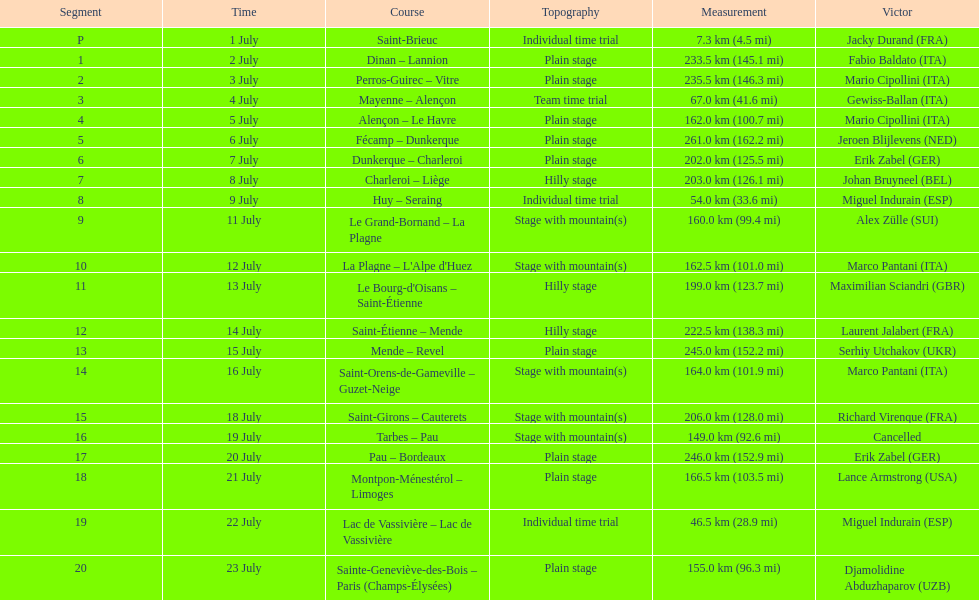Which routes were at least 100 km? Dinan - Lannion, Perros-Guirec - Vitre, Alençon - Le Havre, Fécamp - Dunkerque, Dunkerque - Charleroi, Charleroi - Liège, Le Grand-Bornand - La Plagne, La Plagne - L'Alpe d'Huez, Le Bourg-d'Oisans - Saint-Étienne, Saint-Étienne - Mende, Mende - Revel, Saint-Orens-de-Gameville - Guzet-Neige, Saint-Girons - Cauterets, Tarbes - Pau, Pau - Bordeaux, Montpon-Ménestérol - Limoges, Sainte-Geneviève-des-Bois - Paris (Champs-Élysées). Can you give me this table as a dict? {'header': ['Segment', 'Time', 'Course', 'Topography', 'Measurement', 'Victor'], 'rows': [['P', '1 July', 'Saint-Brieuc', 'Individual time trial', '7.3\xa0km (4.5\xa0mi)', 'Jacky Durand\xa0(FRA)'], ['1', '2 July', 'Dinan – Lannion', 'Plain stage', '233.5\xa0km (145.1\xa0mi)', 'Fabio Baldato\xa0(ITA)'], ['2', '3 July', 'Perros-Guirec – Vitre', 'Plain stage', '235.5\xa0km (146.3\xa0mi)', 'Mario Cipollini\xa0(ITA)'], ['3', '4 July', 'Mayenne – Alençon', 'Team time trial', '67.0\xa0km (41.6\xa0mi)', 'Gewiss-Ballan\xa0(ITA)'], ['4', '5 July', 'Alençon – Le Havre', 'Plain stage', '162.0\xa0km (100.7\xa0mi)', 'Mario Cipollini\xa0(ITA)'], ['5', '6 July', 'Fécamp – Dunkerque', 'Plain stage', '261.0\xa0km (162.2\xa0mi)', 'Jeroen Blijlevens\xa0(NED)'], ['6', '7 July', 'Dunkerque – Charleroi', 'Plain stage', '202.0\xa0km (125.5\xa0mi)', 'Erik Zabel\xa0(GER)'], ['7', '8 July', 'Charleroi – Liège', 'Hilly stage', '203.0\xa0km (126.1\xa0mi)', 'Johan Bruyneel\xa0(BEL)'], ['8', '9 July', 'Huy – Seraing', 'Individual time trial', '54.0\xa0km (33.6\xa0mi)', 'Miguel Indurain\xa0(ESP)'], ['9', '11 July', 'Le Grand-Bornand – La Plagne', 'Stage with mountain(s)', '160.0\xa0km (99.4\xa0mi)', 'Alex Zülle\xa0(SUI)'], ['10', '12 July', "La Plagne – L'Alpe d'Huez", 'Stage with mountain(s)', '162.5\xa0km (101.0\xa0mi)', 'Marco Pantani\xa0(ITA)'], ['11', '13 July', "Le Bourg-d'Oisans – Saint-Étienne", 'Hilly stage', '199.0\xa0km (123.7\xa0mi)', 'Maximilian Sciandri\xa0(GBR)'], ['12', '14 July', 'Saint-Étienne – Mende', 'Hilly stage', '222.5\xa0km (138.3\xa0mi)', 'Laurent Jalabert\xa0(FRA)'], ['13', '15 July', 'Mende – Revel', 'Plain stage', '245.0\xa0km (152.2\xa0mi)', 'Serhiy Utchakov\xa0(UKR)'], ['14', '16 July', 'Saint-Orens-de-Gameville – Guzet-Neige', 'Stage with mountain(s)', '164.0\xa0km (101.9\xa0mi)', 'Marco Pantani\xa0(ITA)'], ['15', '18 July', 'Saint-Girons – Cauterets', 'Stage with mountain(s)', '206.0\xa0km (128.0\xa0mi)', 'Richard Virenque\xa0(FRA)'], ['16', '19 July', 'Tarbes – Pau', 'Stage with mountain(s)', '149.0\xa0km (92.6\xa0mi)', 'Cancelled'], ['17', '20 July', 'Pau – Bordeaux', 'Plain stage', '246.0\xa0km (152.9\xa0mi)', 'Erik Zabel\xa0(GER)'], ['18', '21 July', 'Montpon-Ménestérol – Limoges', 'Plain stage', '166.5\xa0km (103.5\xa0mi)', 'Lance Armstrong\xa0(USA)'], ['19', '22 July', 'Lac de Vassivière – Lac de Vassivière', 'Individual time trial', '46.5\xa0km (28.9\xa0mi)', 'Miguel Indurain\xa0(ESP)'], ['20', '23 July', 'Sainte-Geneviève-des-Bois – Paris (Champs-Élysées)', 'Plain stage', '155.0\xa0km (96.3\xa0mi)', 'Djamolidine Abduzhaparov\xa0(UZB)']]} 